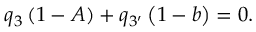Convert formula to latex. <formula><loc_0><loc_0><loc_500><loc_500>q _ { 3 } \left ( 1 - A \right ) + q _ { 3 ^ { \prime } } \left ( 1 - b \right ) = 0 .</formula> 